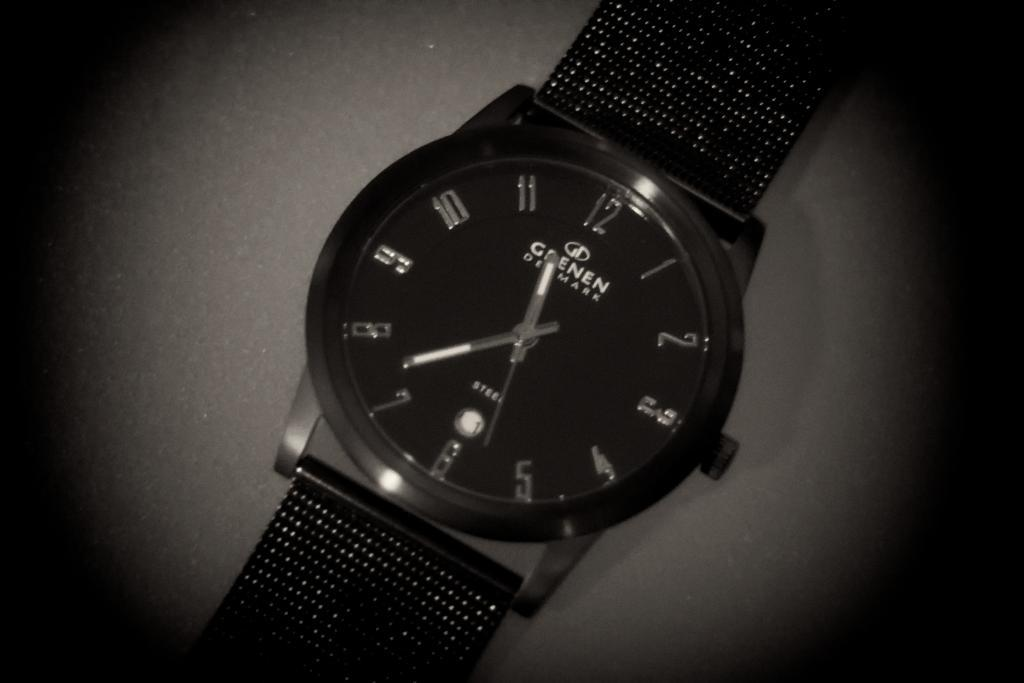<image>
Summarize the visual content of the image. The Grenen Denmark watch shows the time is 11:37. 